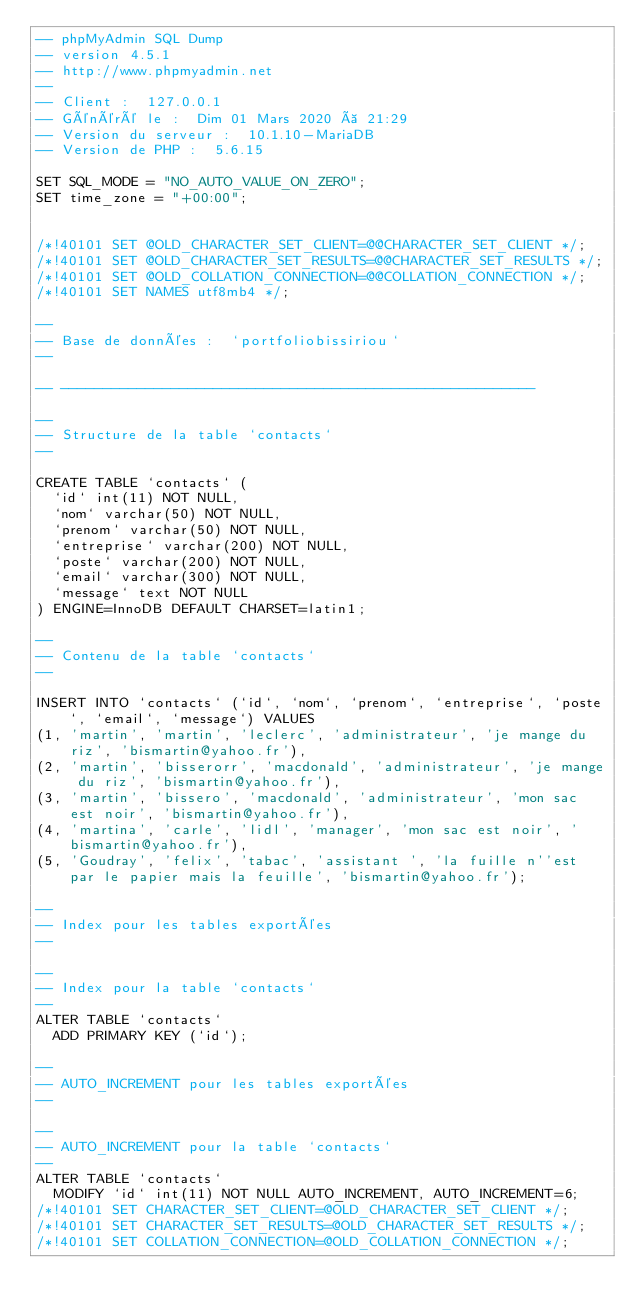Convert code to text. <code><loc_0><loc_0><loc_500><loc_500><_SQL_>-- phpMyAdmin SQL Dump
-- version 4.5.1
-- http://www.phpmyadmin.net
--
-- Client :  127.0.0.1
-- Généré le :  Dim 01 Mars 2020 à 21:29
-- Version du serveur :  10.1.10-MariaDB
-- Version de PHP :  5.6.15

SET SQL_MODE = "NO_AUTO_VALUE_ON_ZERO";
SET time_zone = "+00:00";


/*!40101 SET @OLD_CHARACTER_SET_CLIENT=@@CHARACTER_SET_CLIENT */;
/*!40101 SET @OLD_CHARACTER_SET_RESULTS=@@CHARACTER_SET_RESULTS */;
/*!40101 SET @OLD_COLLATION_CONNECTION=@@COLLATION_CONNECTION */;
/*!40101 SET NAMES utf8mb4 */;

--
-- Base de données :  `portfoliobissiriou`
--

-- --------------------------------------------------------

--
-- Structure de la table `contacts`
--

CREATE TABLE `contacts` (
  `id` int(11) NOT NULL,
  `nom` varchar(50) NOT NULL,
  `prenom` varchar(50) NOT NULL,
  `entreprise` varchar(200) NOT NULL,
  `poste` varchar(200) NOT NULL,
  `email` varchar(300) NOT NULL,
  `message` text NOT NULL
) ENGINE=InnoDB DEFAULT CHARSET=latin1;

--
-- Contenu de la table `contacts`
--

INSERT INTO `contacts` (`id`, `nom`, `prenom`, `entreprise`, `poste`, `email`, `message`) VALUES
(1, 'martin', 'martin', 'leclerc', 'administrateur', 'je mange du riz', 'bismartin@yahoo.fr'),
(2, 'martin', 'bisserorr', 'macdonald', 'administrateur', 'je mange du riz', 'bismartin@yahoo.fr'),
(3, 'martin', 'bissero', 'macdonald', 'administrateur', 'mon sac est noir', 'bismartin@yahoo.fr'),
(4, 'martina', 'carle', 'lidl', 'manager', 'mon sac est noir', 'bismartin@yahoo.fr'),
(5, 'Goudray', 'felix', 'tabac', 'assistant ', 'la fuille n''est par le papier mais la feuille', 'bismartin@yahoo.fr');

--
-- Index pour les tables exportées
--

--
-- Index pour la table `contacts`
--
ALTER TABLE `contacts`
  ADD PRIMARY KEY (`id`);

--
-- AUTO_INCREMENT pour les tables exportées
--

--
-- AUTO_INCREMENT pour la table `contacts`
--
ALTER TABLE `contacts`
  MODIFY `id` int(11) NOT NULL AUTO_INCREMENT, AUTO_INCREMENT=6;
/*!40101 SET CHARACTER_SET_CLIENT=@OLD_CHARACTER_SET_CLIENT */;
/*!40101 SET CHARACTER_SET_RESULTS=@OLD_CHARACTER_SET_RESULTS */;
/*!40101 SET COLLATION_CONNECTION=@OLD_COLLATION_CONNECTION */;
</code> 